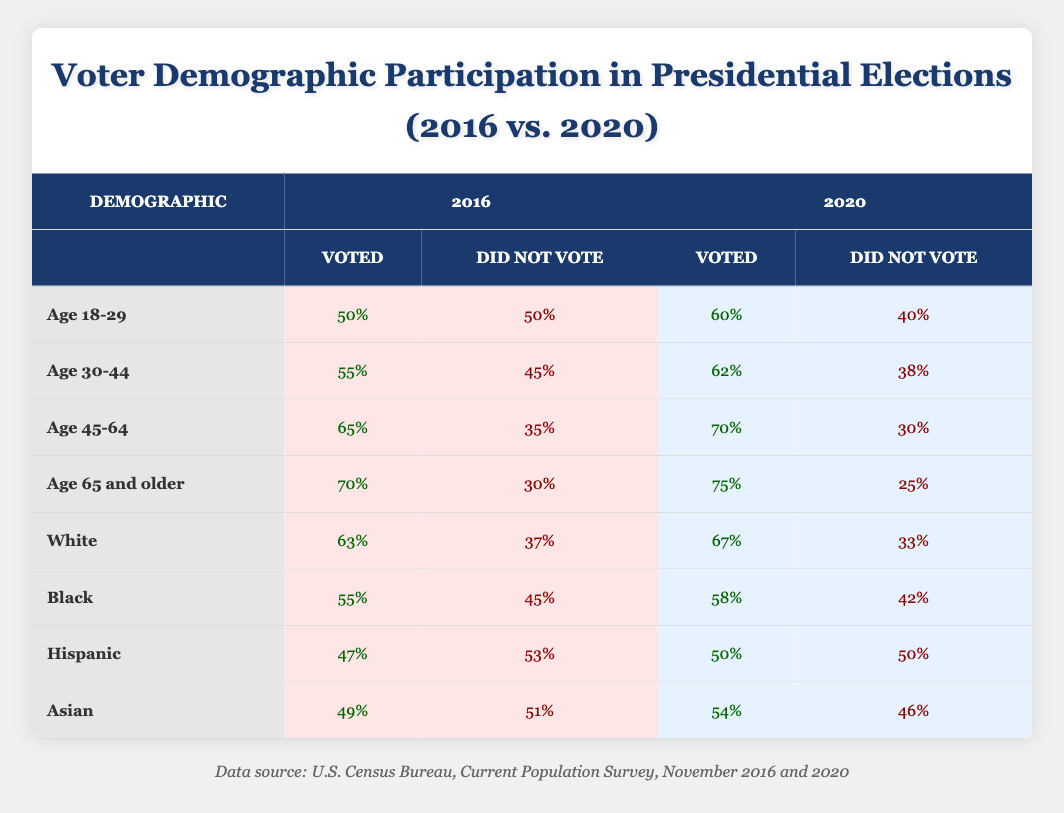What was the voter percentage for the demographic Age 65 and older in 2020? The table shows that 75% of the Age 65 and older demographic voted in the 2020 presidential election.
Answer: 75% Did the percentage of Hispanic voters increase or decrease from 2016 to 2020? In 2016, 47% of Hispanic voters voted, while in 2020, 50% voted. This is an increase.
Answer: Increase What is the difference in voter turnout between Age 45-64 in 2016 and 2020? The turnout for Age 45-64 was 65% in 2016 and 70% in 2020. The difference is 70% - 65% = 5%.
Answer: 5% True or False: More than half of Black voters participated in the 2016 election. The table indicates that 55% of Black voters voted in 2016, which is indeed more than half.
Answer: True What is the average voting percentage for all demographics in 2020? The percentages for 2020 are 60%, 62%, 70%, 75%, 67%, 58%, 50%, and 54%. Summing these gives 60 + 62 + 70 + 75 + 67 + 58 + 50 + 54 = 456. There are 8 demographics, so the average is 456/8 = 57%.
Answer: 57% What percentage of Asian voters did not participate in the 2020 election? According to the table, 46% of Asian voters did not vote in the 2020 election.
Answer: 46% True or False: More voters aged 30-44 participated in the 2016 election than those aged 18-29. The table shows 55% of Age 30-44 voted and 50% of Age 18-29 voted in 2016. Therefore, this statement is true.
Answer: True How many more percentage points did the Age 18-29 demographic improve in voter turnout from 2016 to 2020? The Age 18-29 demographic voted 50% in 2016 and increased to 60% in 2020. The improvement is 60% - 50% = 10 percentage points.
Answer: 10 percentage points 